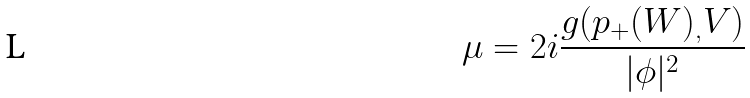<formula> <loc_0><loc_0><loc_500><loc_500>\mu = 2 i \frac { g ( p _ { + } ( W ) _ { , } V ) } { | \phi | ^ { 2 } }</formula> 